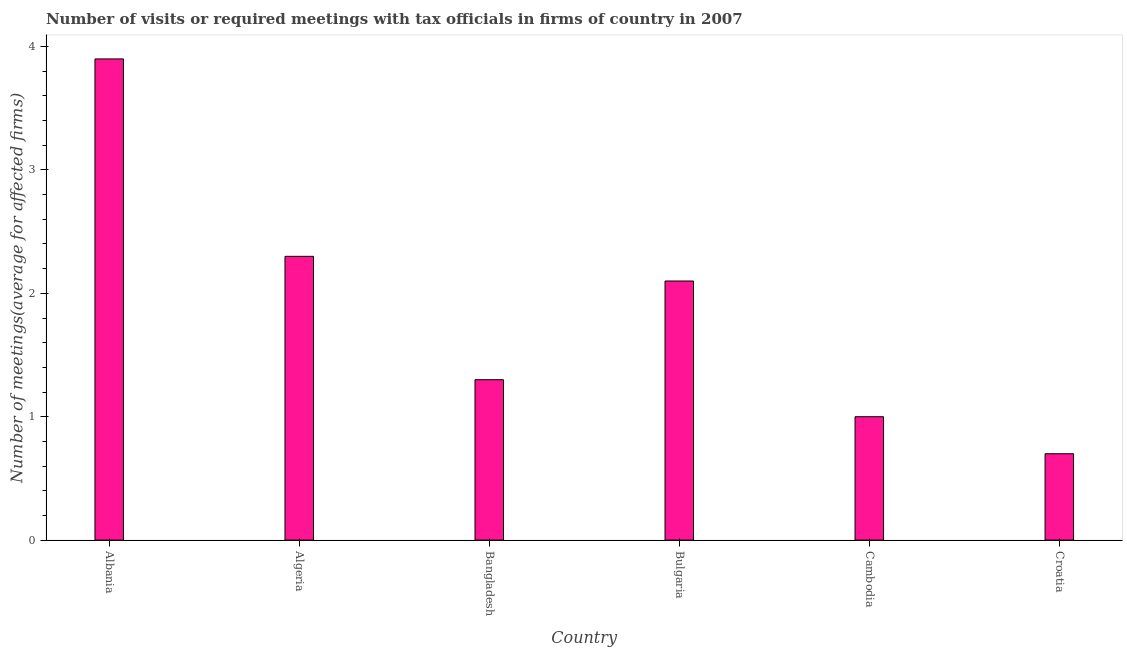Does the graph contain grids?
Give a very brief answer. No. What is the title of the graph?
Give a very brief answer. Number of visits or required meetings with tax officials in firms of country in 2007. What is the label or title of the Y-axis?
Give a very brief answer. Number of meetings(average for affected firms). Across all countries, what is the maximum number of required meetings with tax officials?
Your response must be concise. 3.9. Across all countries, what is the minimum number of required meetings with tax officials?
Your answer should be very brief. 0.7. In which country was the number of required meetings with tax officials maximum?
Your answer should be very brief. Albania. In which country was the number of required meetings with tax officials minimum?
Provide a succinct answer. Croatia. What is the sum of the number of required meetings with tax officials?
Offer a terse response. 11.3. What is the average number of required meetings with tax officials per country?
Provide a succinct answer. 1.88. What is the median number of required meetings with tax officials?
Your answer should be very brief. 1.7. What is the ratio of the number of required meetings with tax officials in Albania to that in Cambodia?
Ensure brevity in your answer.  3.9. Is the number of required meetings with tax officials in Algeria less than that in Bulgaria?
Provide a short and direct response. No. What is the difference between the highest and the second highest number of required meetings with tax officials?
Make the answer very short. 1.6. In how many countries, is the number of required meetings with tax officials greater than the average number of required meetings with tax officials taken over all countries?
Ensure brevity in your answer.  3. How many bars are there?
Your answer should be compact. 6. Are all the bars in the graph horizontal?
Your answer should be very brief. No. Are the values on the major ticks of Y-axis written in scientific E-notation?
Provide a short and direct response. No. What is the Number of meetings(average for affected firms) in Albania?
Give a very brief answer. 3.9. What is the Number of meetings(average for affected firms) in Algeria?
Give a very brief answer. 2.3. What is the Number of meetings(average for affected firms) in Bangladesh?
Your answer should be compact. 1.3. What is the Number of meetings(average for affected firms) in Cambodia?
Give a very brief answer. 1. What is the difference between the Number of meetings(average for affected firms) in Albania and Algeria?
Provide a short and direct response. 1.6. What is the difference between the Number of meetings(average for affected firms) in Albania and Bulgaria?
Your answer should be very brief. 1.8. What is the difference between the Number of meetings(average for affected firms) in Albania and Cambodia?
Your answer should be very brief. 2.9. What is the difference between the Number of meetings(average for affected firms) in Algeria and Bangladesh?
Provide a succinct answer. 1. What is the difference between the Number of meetings(average for affected firms) in Bangladesh and Bulgaria?
Your response must be concise. -0.8. What is the difference between the Number of meetings(average for affected firms) in Bangladesh and Cambodia?
Provide a succinct answer. 0.3. What is the difference between the Number of meetings(average for affected firms) in Bangladesh and Croatia?
Your answer should be compact. 0.6. What is the difference between the Number of meetings(average for affected firms) in Cambodia and Croatia?
Offer a very short reply. 0.3. What is the ratio of the Number of meetings(average for affected firms) in Albania to that in Algeria?
Keep it short and to the point. 1.7. What is the ratio of the Number of meetings(average for affected firms) in Albania to that in Bangladesh?
Your response must be concise. 3. What is the ratio of the Number of meetings(average for affected firms) in Albania to that in Bulgaria?
Ensure brevity in your answer.  1.86. What is the ratio of the Number of meetings(average for affected firms) in Albania to that in Croatia?
Make the answer very short. 5.57. What is the ratio of the Number of meetings(average for affected firms) in Algeria to that in Bangladesh?
Your answer should be compact. 1.77. What is the ratio of the Number of meetings(average for affected firms) in Algeria to that in Bulgaria?
Give a very brief answer. 1.09. What is the ratio of the Number of meetings(average for affected firms) in Algeria to that in Croatia?
Your answer should be very brief. 3.29. What is the ratio of the Number of meetings(average for affected firms) in Bangladesh to that in Bulgaria?
Provide a short and direct response. 0.62. What is the ratio of the Number of meetings(average for affected firms) in Bangladesh to that in Croatia?
Offer a terse response. 1.86. What is the ratio of the Number of meetings(average for affected firms) in Bulgaria to that in Croatia?
Offer a very short reply. 3. What is the ratio of the Number of meetings(average for affected firms) in Cambodia to that in Croatia?
Keep it short and to the point. 1.43. 